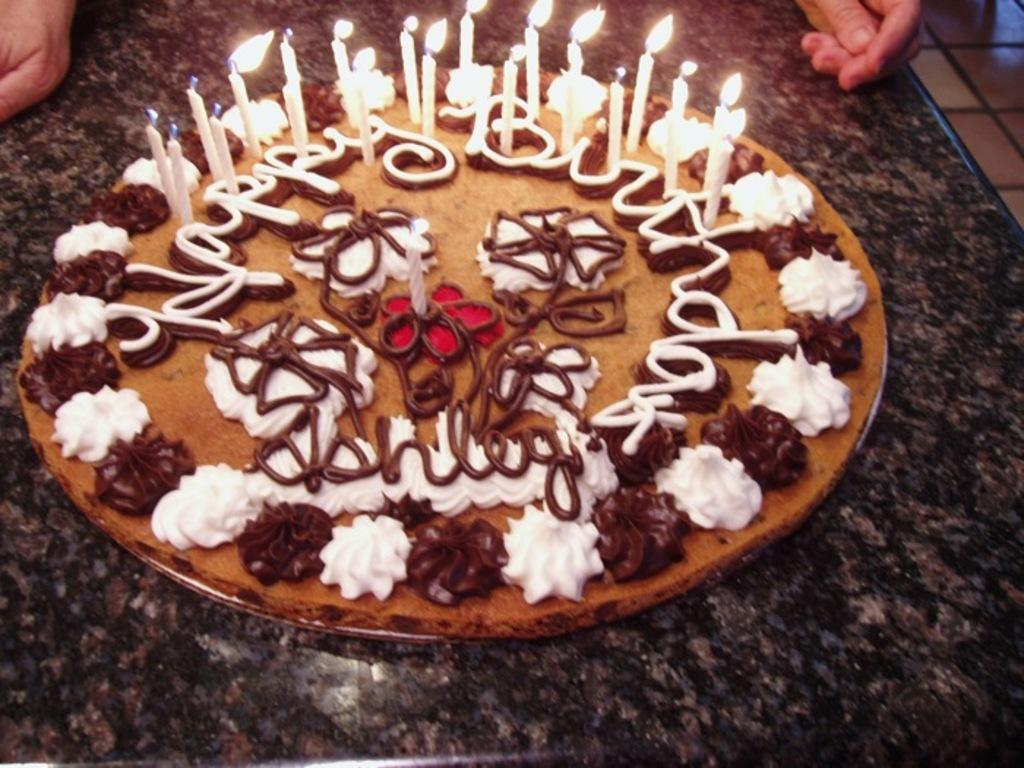What is the main subject of the image? There is a cake with candles in the image. Where is the cake located? The cake is placed on a countertop. Can you describe any other elements in the image? There are hands of a person visible in the background of the image. What type of pet can be seen getting a haircut in the image? There is no pet or haircut present in the image; it features a cake with candles on a countertop and hands in the background. 